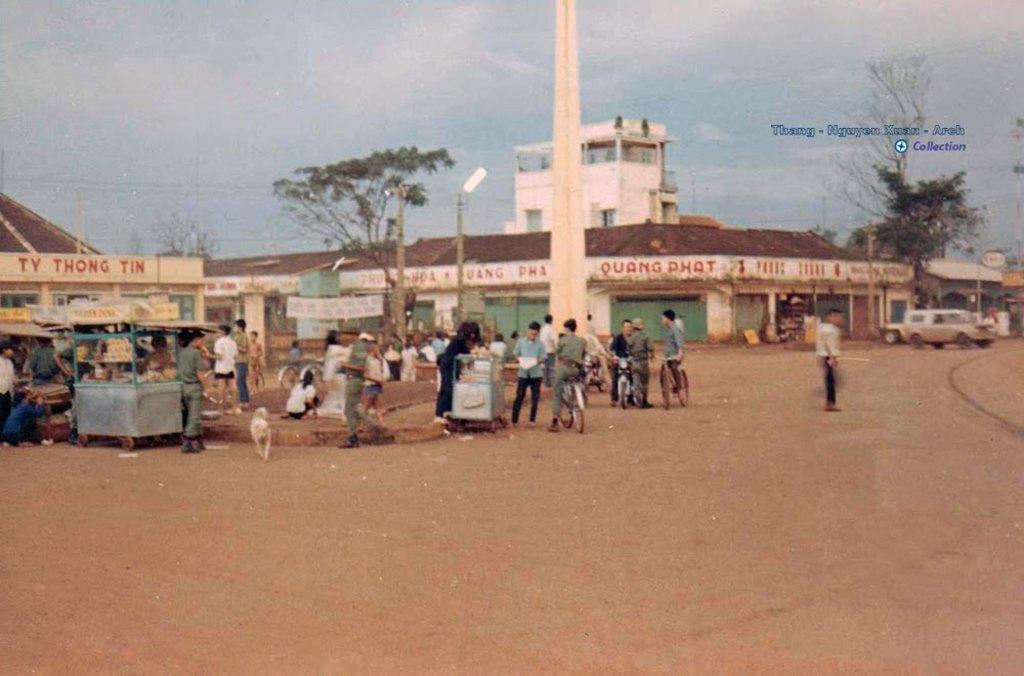In one or two sentences, can you explain what this image depicts? In this picture there are group of people standing and there are group of people sitting. At the back there are buildings, trees and poles and there are vehicles. On the left side of the image there is a stall and there is text on the buildings. At the top there is sky and there are clouds. At the top right there is text. At the bottom there is mud. 